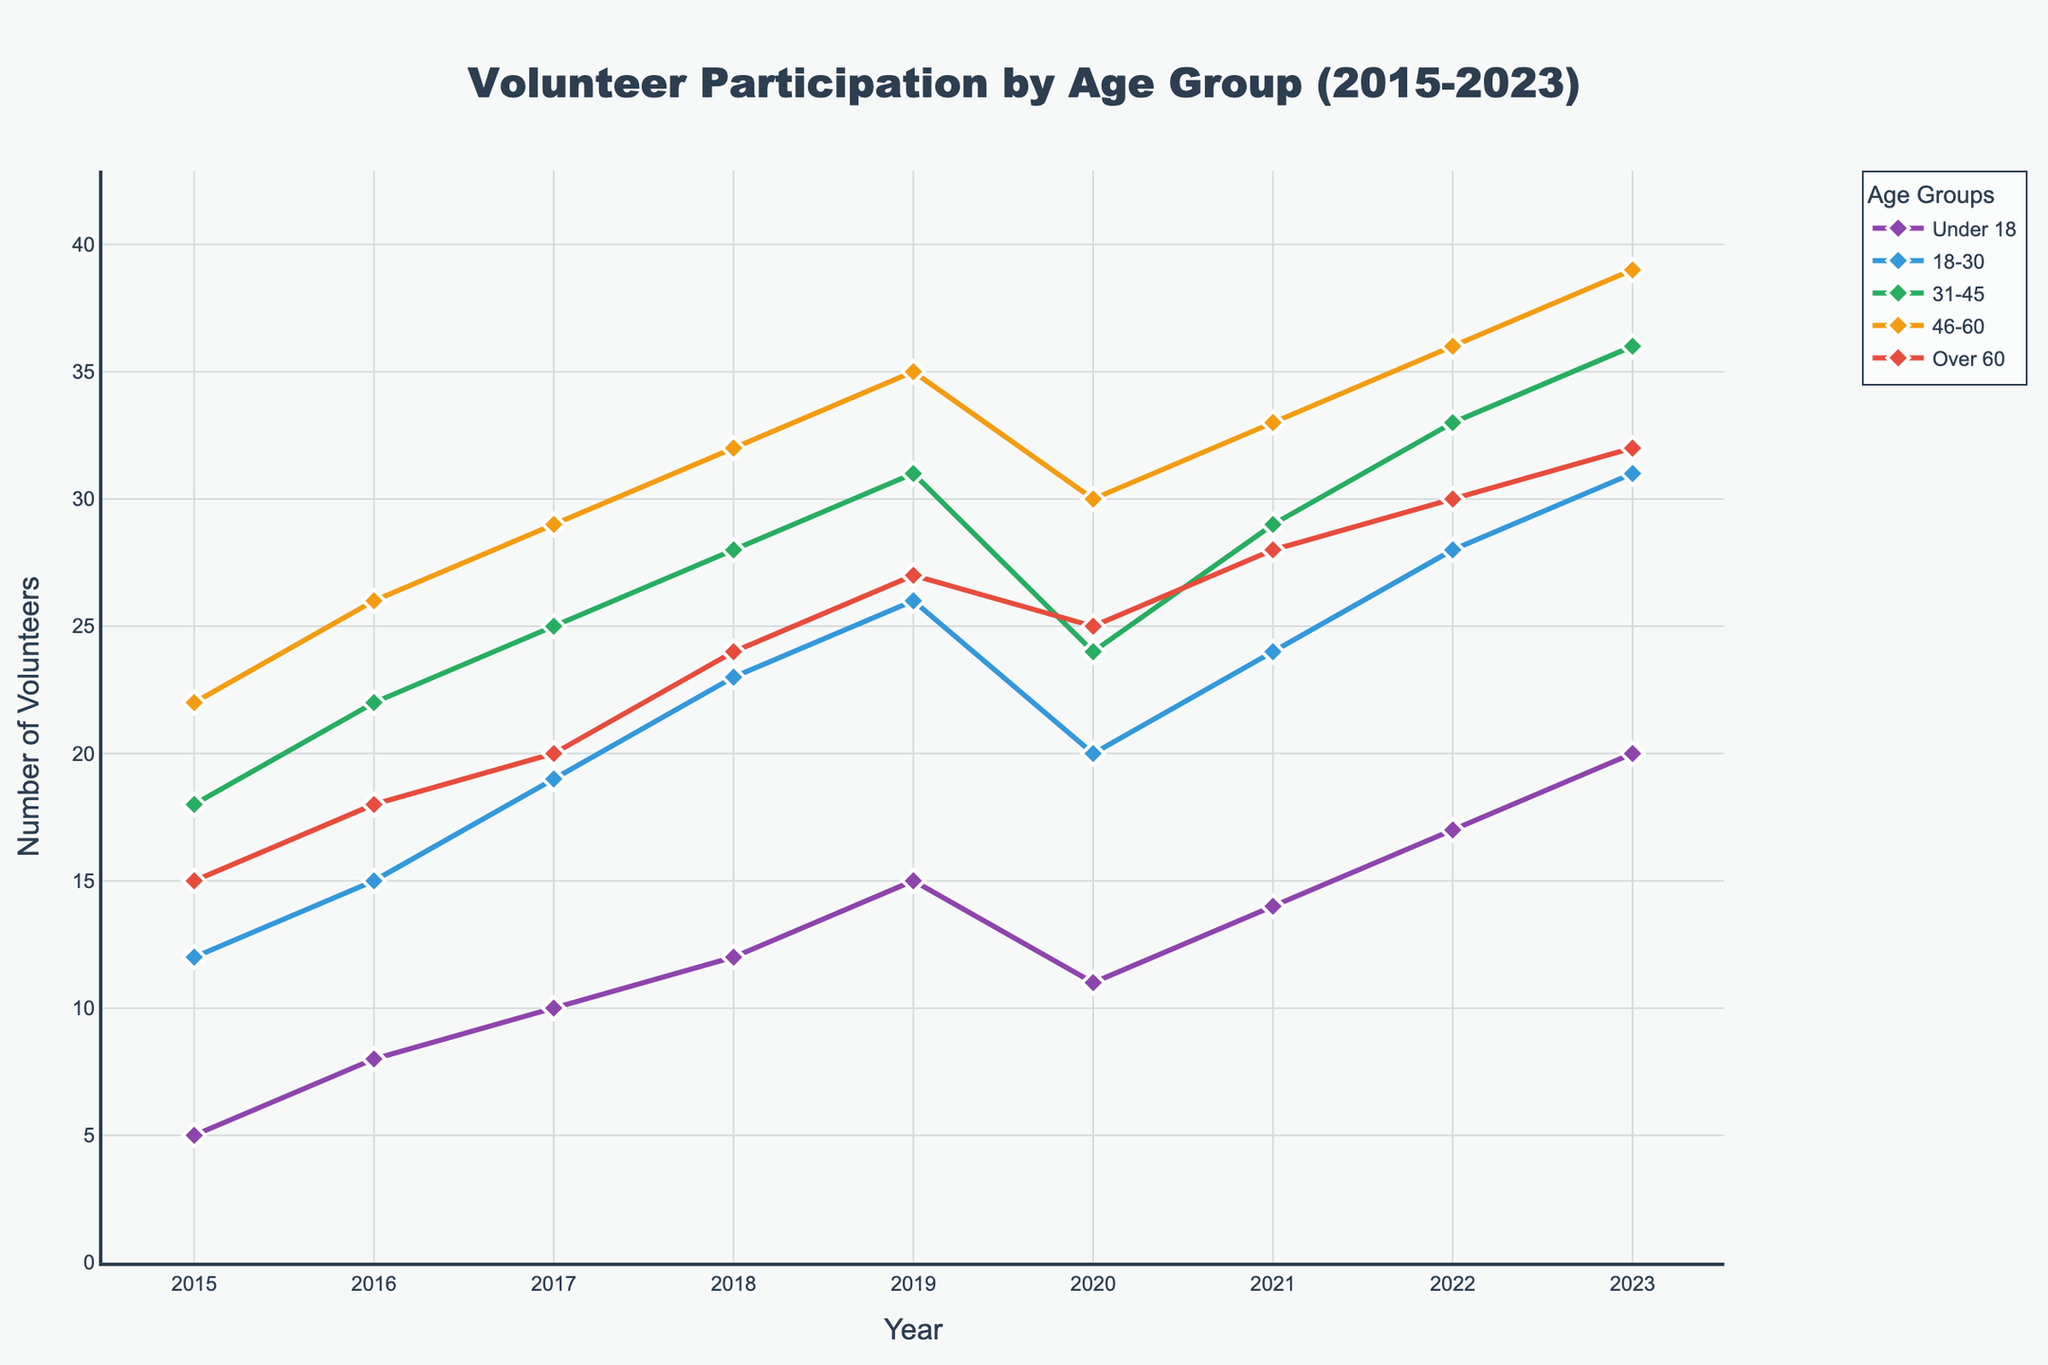What is the trend in volunteer participation for the "Under 18" age group from 2015 to 2023? To find the trend, look at the points and the line representing the "Under 18" group from the beginning (2015) to the end (2023). The number increases steadily from 5 in 2015 to 20 in 2023.
Answer: Increasing Which age group had the highest participation in 2023? In 2023, compare the endpoints of all the lines representing each age group. The "46-60" group has the highest point with 39 volunteers.
Answer: 46-60 Between which years did the "18-30" age group see the largest increase in participation? Look at the "18-30" age group line. The slope is steepest between 2021 and 2022, increasing from 24 to 28 volunteers.
Answer: 2021 to 2022 What is the combined number of volunteers for the "31-45" and "Over 60" age groups in 2020? Add the two values for 2020: "31-45" has 24 and "Over 60" has 25; total is 24 + 25 = 49.
Answer: 49 Which age group showed the most variability in volunteer participation from 2015 to 2023? Determine each group's variability by looking at fluctuations in the lines. The "Under 18" group shows the most consistent increase without significant drops or spikes.
Answer: Under 18 What is the average number of volunteers in 2020 across all age groups? Sum the values for 2020: (11 + 20 + 24 + 30 + 25 = 110). Average: 110 / 5 = 22.
Answer: 22 How did participation for the "Over 60" age group change from 2019 to 2020? Compare the points for 2019 (27 volunteers) and 2020 (25 volunteers); there is a decrease of 2.
Answer: Decreased by 2 In which year did the "46-60" age group first reach above 30 volunteers? Observe the point where the "46-60" line first crosses above 30, which occurs in 2018 with 32 volunteers.
Answer: 2018 Which two age groups had the closest number of volunteers in 2023? Compare the endpoints for each age group in 2023. The "31-45" (36) and "46-60" (39) groups are the closest.
Answer: 31-45 and 46-60 